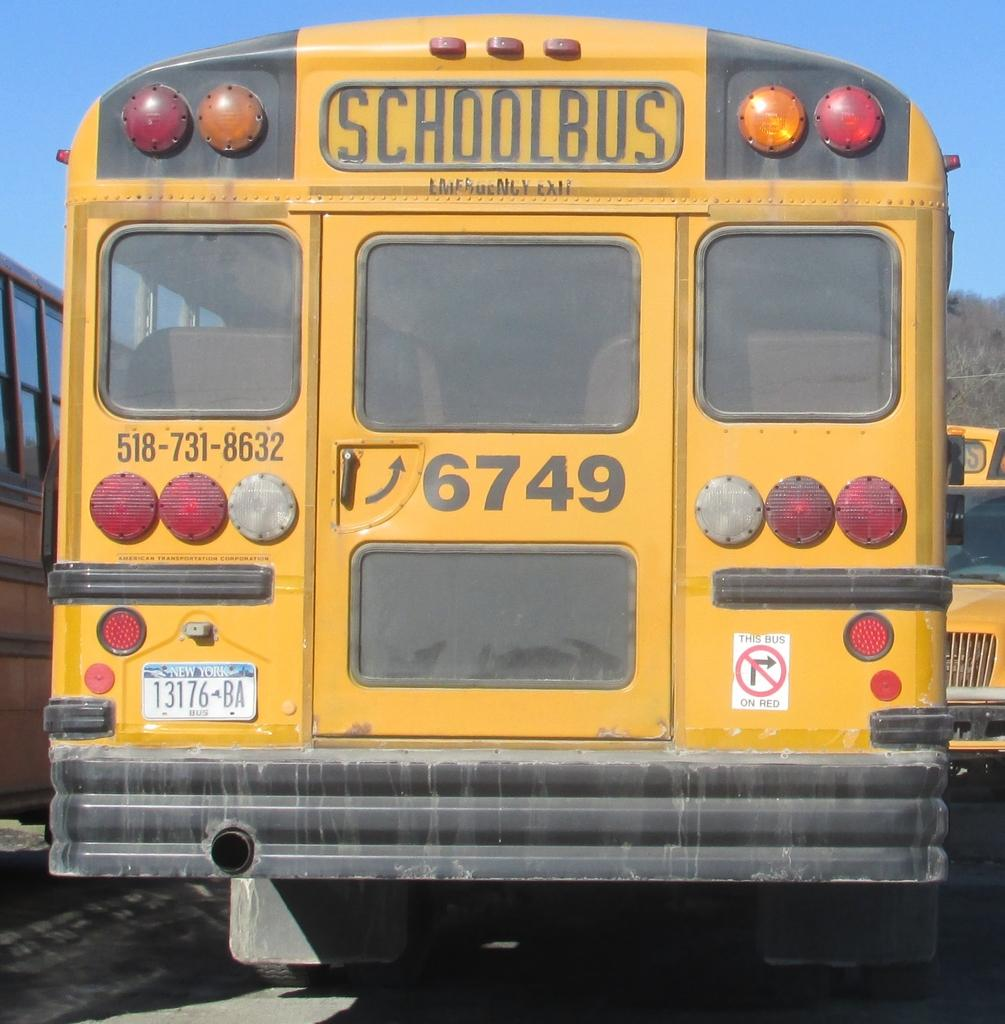What type of vehicles are in the image? There are school buses in the image. What distinguishes the school buses from other vehicles? The school buses have texts and numbers on them. What can be seen in the background of the image? The sky is visible in the image. What invention is being demonstrated in the image? There is no invention being demonstrated in the image; it features school buses with texts and numbers on them. How does the station help the school buses in the image? There is no station present in the image, and therefore it cannot help the school buses. 